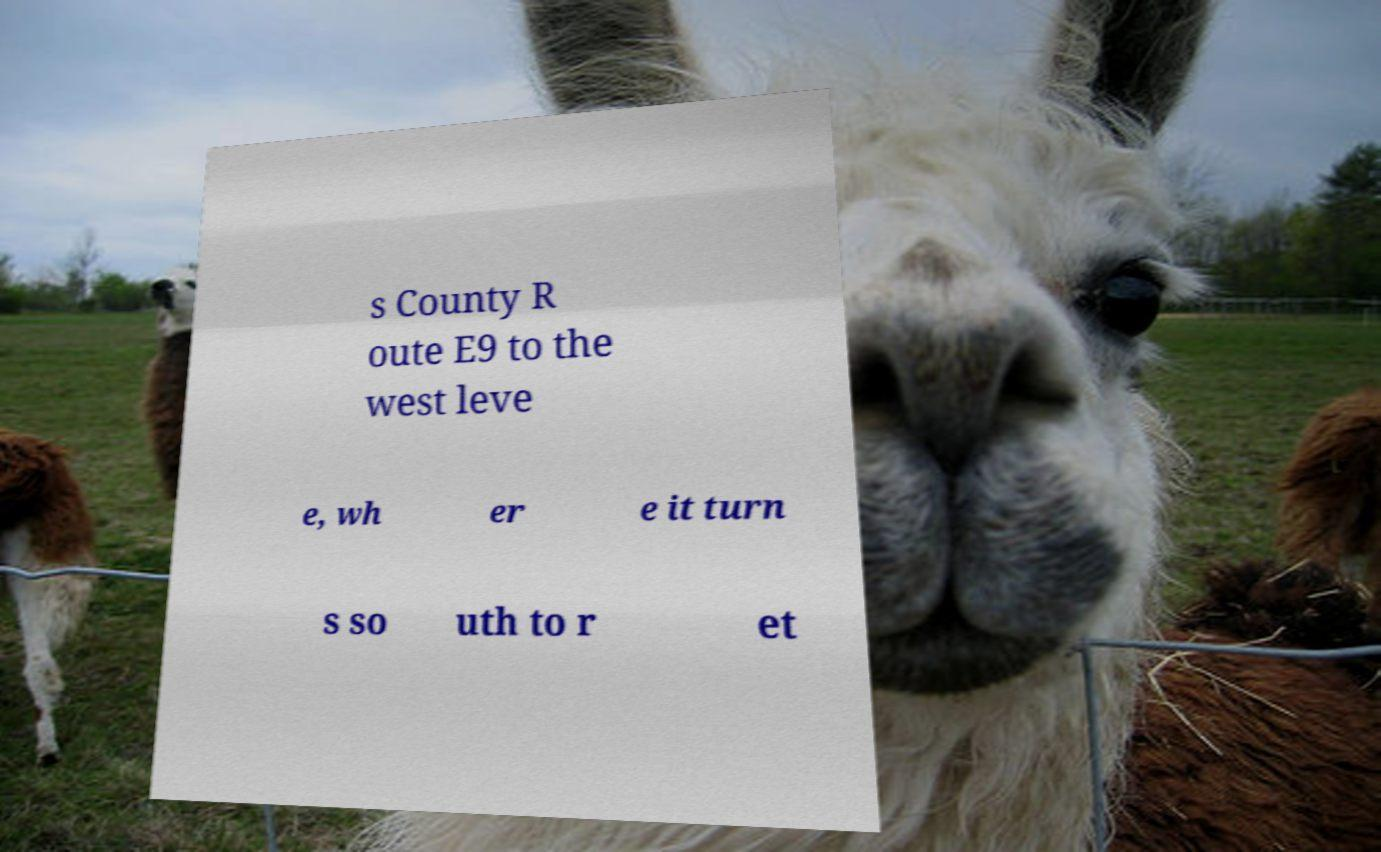Please identify and transcribe the text found in this image. s County R oute E9 to the west leve e, wh er e it turn s so uth to r et 